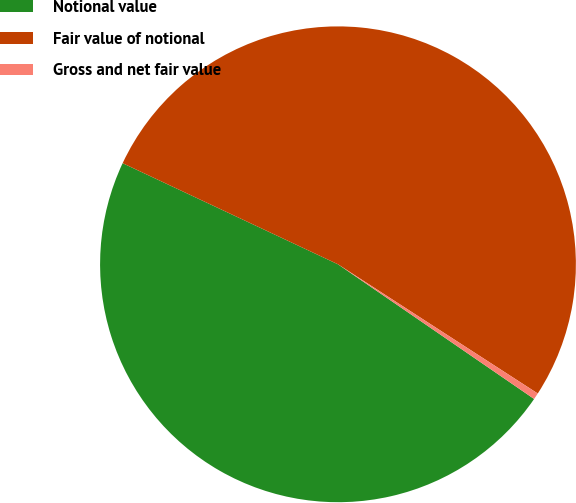Convert chart to OTSL. <chart><loc_0><loc_0><loc_500><loc_500><pie_chart><fcel>Notional value<fcel>Fair value of notional<fcel>Gross and net fair value<nl><fcel>47.41%<fcel>52.15%<fcel>0.44%<nl></chart> 